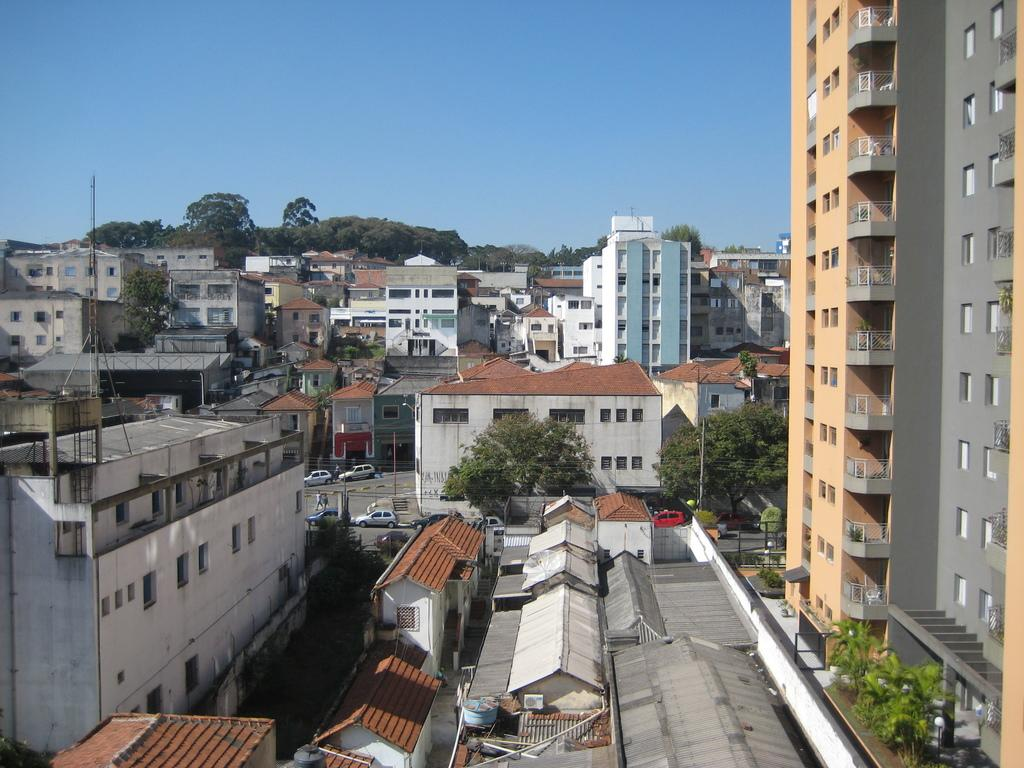What type of natural elements can be seen in the image? There are trees in the image. What type of man-made structures are present in the image? There are buildings in the image. What type of transportation is visible in the image? There are vehicles in the image. What type of vertical structures can be seen in the image? There are poles in the image. What is visible at the top of the image? The sky is visible at the top of the image. Where is the toad sitting in the image? There is no toad present in the image. What type of lamp is illuminating the area in the image? There is no lamp present in the image. 